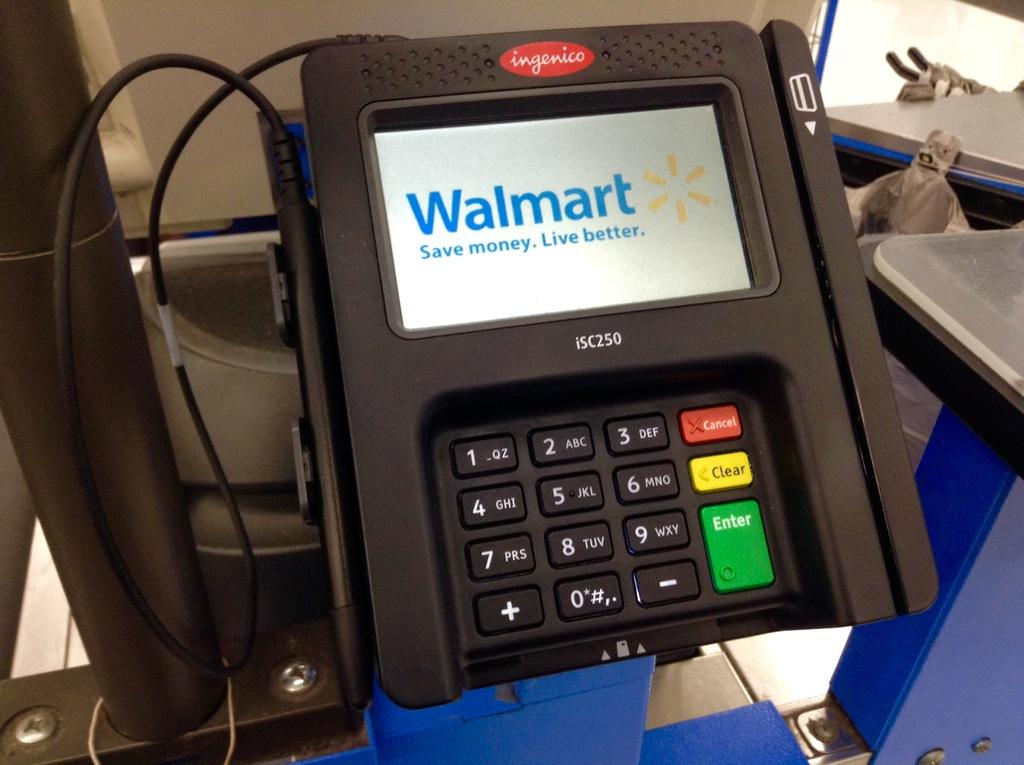What type of electronic device is visible in the image? The specific type of electronic device is not mentioned, but there is an electronic device in the image. What color is the object at the bottom of the image? The object at the bottom of the image is blue. Where is the table located in the image? The table is on the right side of the image. What is the pole used for in the image? The purpose of the pole is not mentioned, but there is a pole in the image. What material are the metal objects made of in the image? The metal objects in the image are made of metal. Can you see any sea creatures swimming near the blue object in the image? There is no sea or sea creatures present in the image; it features an electronic device, a blue object, a table, a pole, and metal objects. Is there a bun on the table in the image? There is no bun present in the image. 